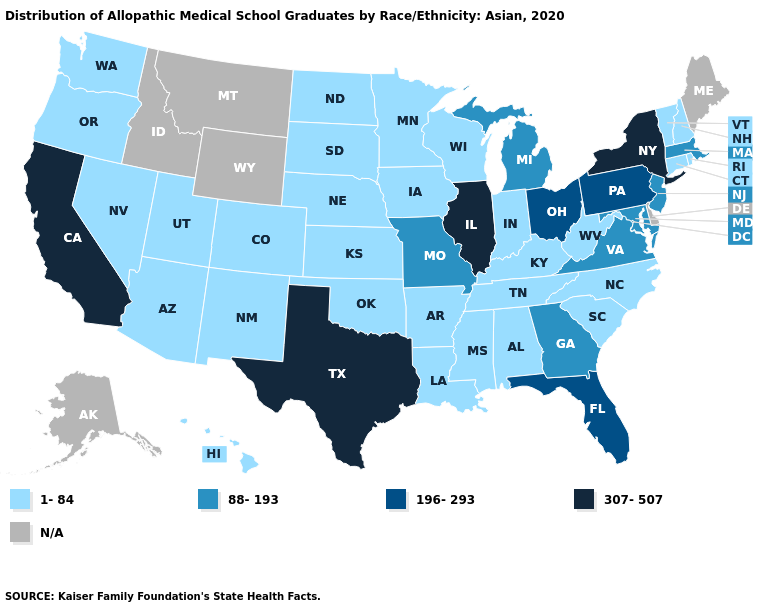Does Illinois have the highest value in the USA?
Concise answer only. Yes. What is the highest value in the USA?
Keep it brief. 307-507. Name the states that have a value in the range 88-193?
Concise answer only. Georgia, Maryland, Massachusetts, Michigan, Missouri, New Jersey, Virginia. Name the states that have a value in the range 88-193?
Quick response, please. Georgia, Maryland, Massachusetts, Michigan, Missouri, New Jersey, Virginia. Name the states that have a value in the range N/A?
Short answer required. Alaska, Delaware, Idaho, Maine, Montana, Wyoming. Which states have the highest value in the USA?
Be succinct. California, Illinois, New York, Texas. What is the value of New Hampshire?
Write a very short answer. 1-84. Which states hav the highest value in the MidWest?
Keep it brief. Illinois. Does Mississippi have the highest value in the South?
Give a very brief answer. No. Name the states that have a value in the range 88-193?
Be succinct. Georgia, Maryland, Massachusetts, Michigan, Missouri, New Jersey, Virginia. Does Minnesota have the lowest value in the USA?
Answer briefly. Yes. Does New York have the highest value in the Northeast?
Concise answer only. Yes. Does Ohio have the lowest value in the MidWest?
Answer briefly. No. Among the states that border Florida , does Alabama have the highest value?
Be succinct. No. 